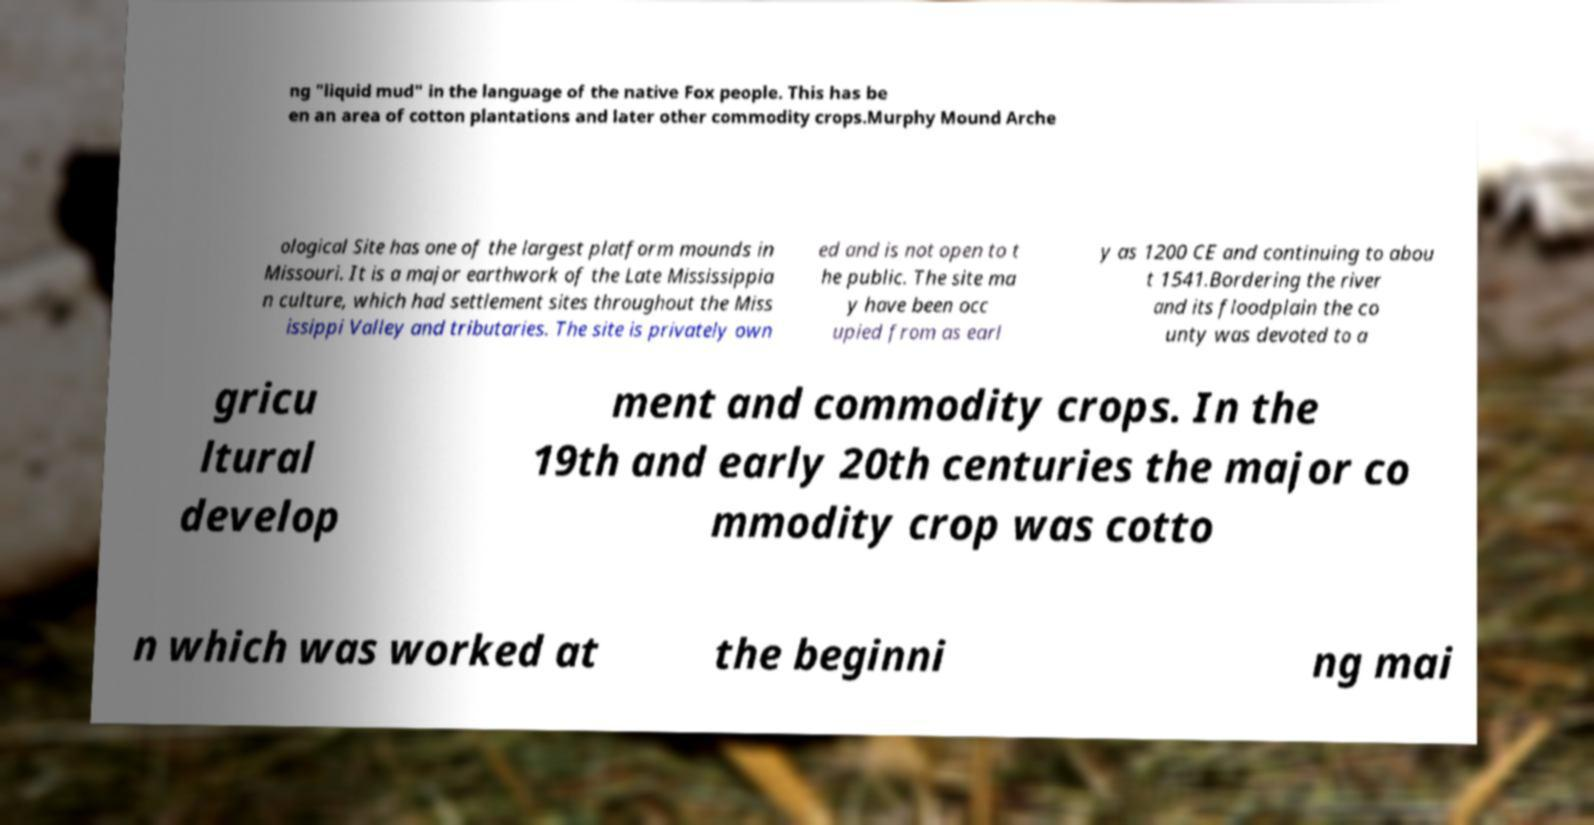What messages or text are displayed in this image? I need them in a readable, typed format. ng "liquid mud" in the language of the native Fox people. This has be en an area of cotton plantations and later other commodity crops.Murphy Mound Arche ological Site has one of the largest platform mounds in Missouri. It is a major earthwork of the Late Mississippia n culture, which had settlement sites throughout the Miss issippi Valley and tributaries. The site is privately own ed and is not open to t he public. The site ma y have been occ upied from as earl y as 1200 CE and continuing to abou t 1541.Bordering the river and its floodplain the co unty was devoted to a gricu ltural develop ment and commodity crops. In the 19th and early 20th centuries the major co mmodity crop was cotto n which was worked at the beginni ng mai 